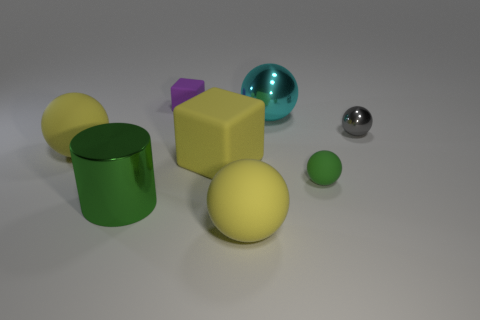Subtract all green balls. How many balls are left? 4 Subtract all green balls. How many balls are left? 4 Subtract all blue balls. Subtract all purple cylinders. How many balls are left? 5 Add 1 green shiny cylinders. How many objects exist? 9 Subtract all cylinders. How many objects are left? 7 Add 6 purple cylinders. How many purple cylinders exist? 6 Subtract 0 blue blocks. How many objects are left? 8 Subtract all large cubes. Subtract all tiny metal spheres. How many objects are left? 6 Add 7 large green things. How many large green things are left? 8 